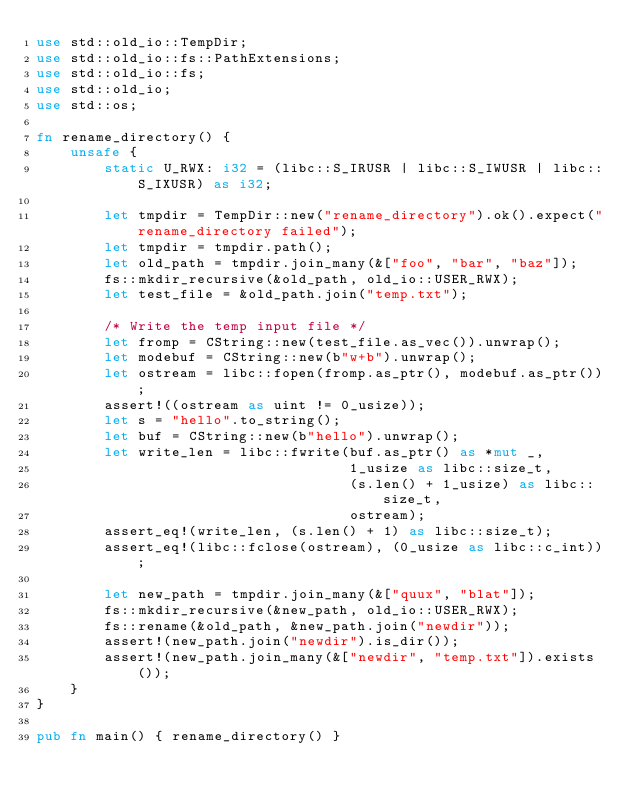<code> <loc_0><loc_0><loc_500><loc_500><_Rust_>use std::old_io::TempDir;
use std::old_io::fs::PathExtensions;
use std::old_io::fs;
use std::old_io;
use std::os;

fn rename_directory() {
    unsafe {
        static U_RWX: i32 = (libc::S_IRUSR | libc::S_IWUSR | libc::S_IXUSR) as i32;

        let tmpdir = TempDir::new("rename_directory").ok().expect("rename_directory failed");
        let tmpdir = tmpdir.path();
        let old_path = tmpdir.join_many(&["foo", "bar", "baz"]);
        fs::mkdir_recursive(&old_path, old_io::USER_RWX);
        let test_file = &old_path.join("temp.txt");

        /* Write the temp input file */
        let fromp = CString::new(test_file.as_vec()).unwrap();
        let modebuf = CString::new(b"w+b").unwrap();
        let ostream = libc::fopen(fromp.as_ptr(), modebuf.as_ptr());
        assert!((ostream as uint != 0_usize));
        let s = "hello".to_string();
        let buf = CString::new(b"hello").unwrap();
        let write_len = libc::fwrite(buf.as_ptr() as *mut _,
                                     1_usize as libc::size_t,
                                     (s.len() + 1_usize) as libc::size_t,
                                     ostream);
        assert_eq!(write_len, (s.len() + 1) as libc::size_t);
        assert_eq!(libc::fclose(ostream), (0_usize as libc::c_int));

        let new_path = tmpdir.join_many(&["quux", "blat"]);
        fs::mkdir_recursive(&new_path, old_io::USER_RWX);
        fs::rename(&old_path, &new_path.join("newdir"));
        assert!(new_path.join("newdir").is_dir());
        assert!(new_path.join_many(&["newdir", "temp.txt"]).exists());
    }
}

pub fn main() { rename_directory() }
</code> 